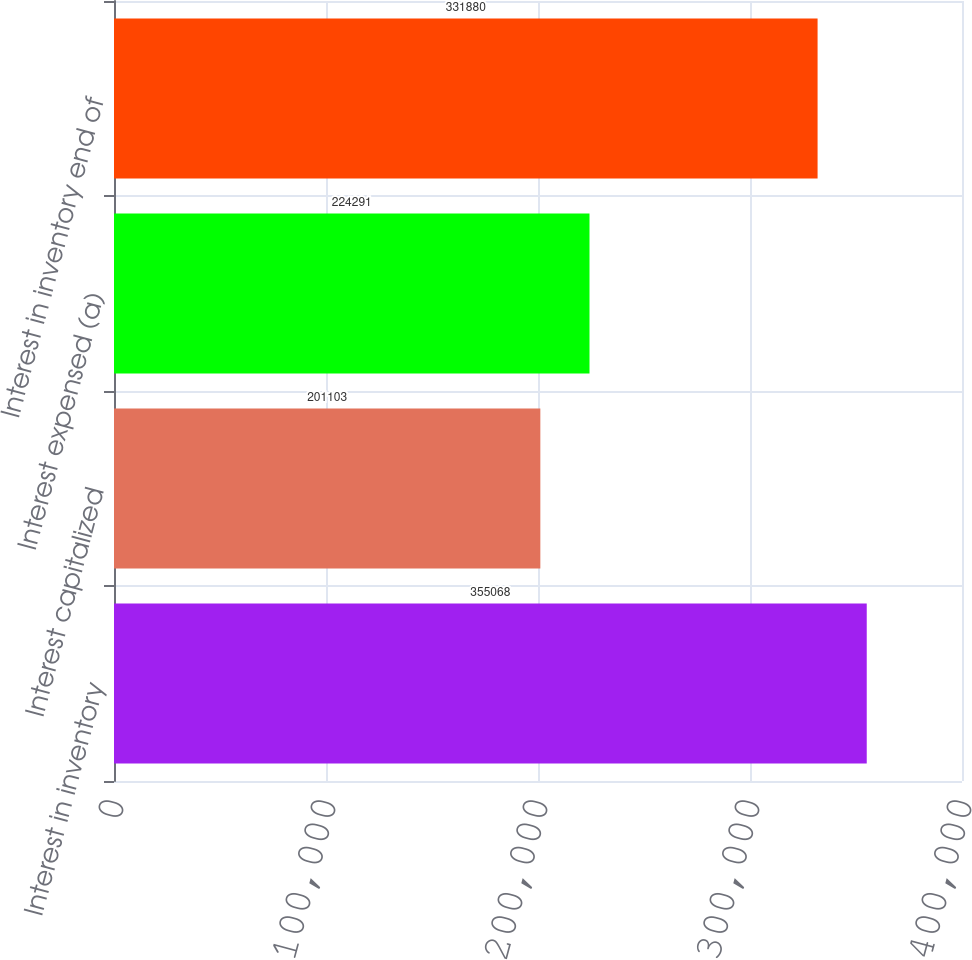Convert chart to OTSL. <chart><loc_0><loc_0><loc_500><loc_500><bar_chart><fcel>Interest in inventory<fcel>Interest capitalized<fcel>Interest expensed (a)<fcel>Interest in inventory end of<nl><fcel>355068<fcel>201103<fcel>224291<fcel>331880<nl></chart> 